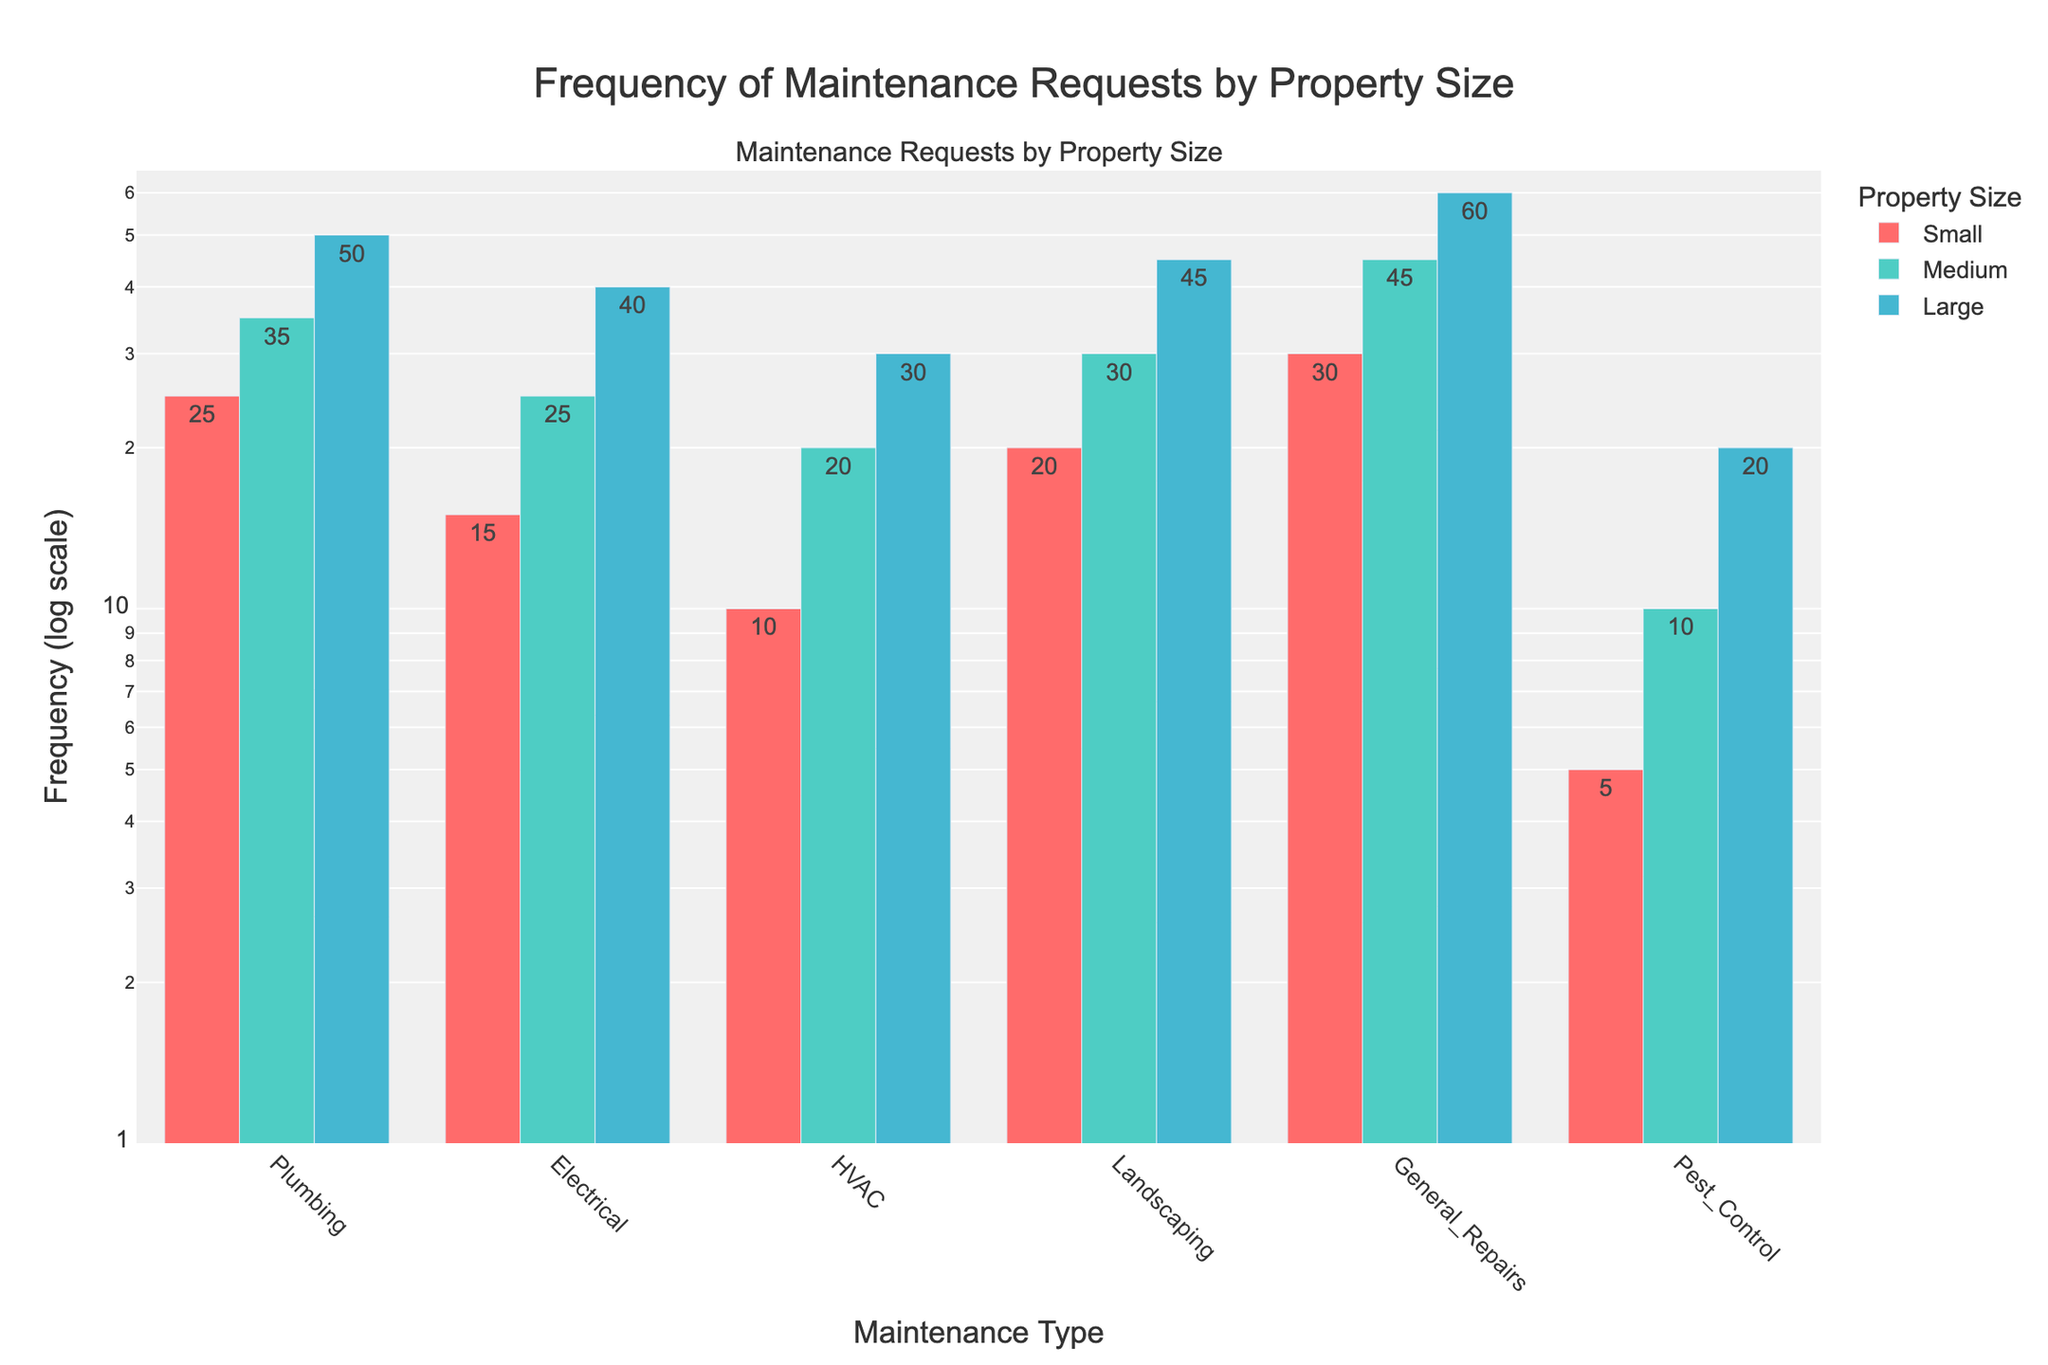How many types of maintenance requests are there in total? There are six different maintenance types listed on the x-axis (Plumbing, Electrical, HVAC, Landscaping, General Repairs, Pest Control).
Answer: 6 Which property size has the highest frequency of Electrical maintenance requests? The bar for Electrical maintenance requests for Large properties is highest compared to Small and Medium properties.
Answer: Large What's the total frequency of Plumbing requests across all property sizes? Summing the frequencies for Small (25), Medium (35), and Large (50) gives us 25 + 35 + 50.
Answer: 110 Which maintenance type has the lowest frequency for Small properties? The bar for Pest Control is the lowest among all maintenance types for Small properties.
Answer: Pest Control How does the frequency of General Repairs compare between Medium and Large properties? The bar for General Repairs is taller for Large properties (60) compared to Medium properties (45).
Answer: Larger in Large properties What’s the combined frequency of HVAC and Landscaping requests for Medium properties? Summing the frequencies for HVAC (20) and Landscaping (30) for Medium properties gives us 20 + 30.
Answer: 50 What type of maintenance request is the most frequent across any property size? The bar for General Repairs for Large properties is the highest among all maintenance types and property sizes.
Answer: General Repairs What's the combined frequency of all maintenance types for Small properties? Summing the frequencies of all maintenance types for Small properties: 25 (Plumbing) + 15 (Electrical) + 10 (HVAC) + 20 (Landscaping) + 30 (General Repairs) + 5 (Pest Control).
Answer: 105 Which property size has the smallest difference in frequency between Plumbing and Electrical requests? The differences for each property size are: Small (25 - 15 = 10), Medium (35 - 25 = 10), Large (50 - 40 = 10). All differences are the same.
Answer: All are equal How does Pest Control request frequency scale from Small to Large properties? The frequencies for Pest Control are 5 (Small), 10 (Medium), and 20 (Large). Each level up, the frequency doubles.
Answer: It doubles 